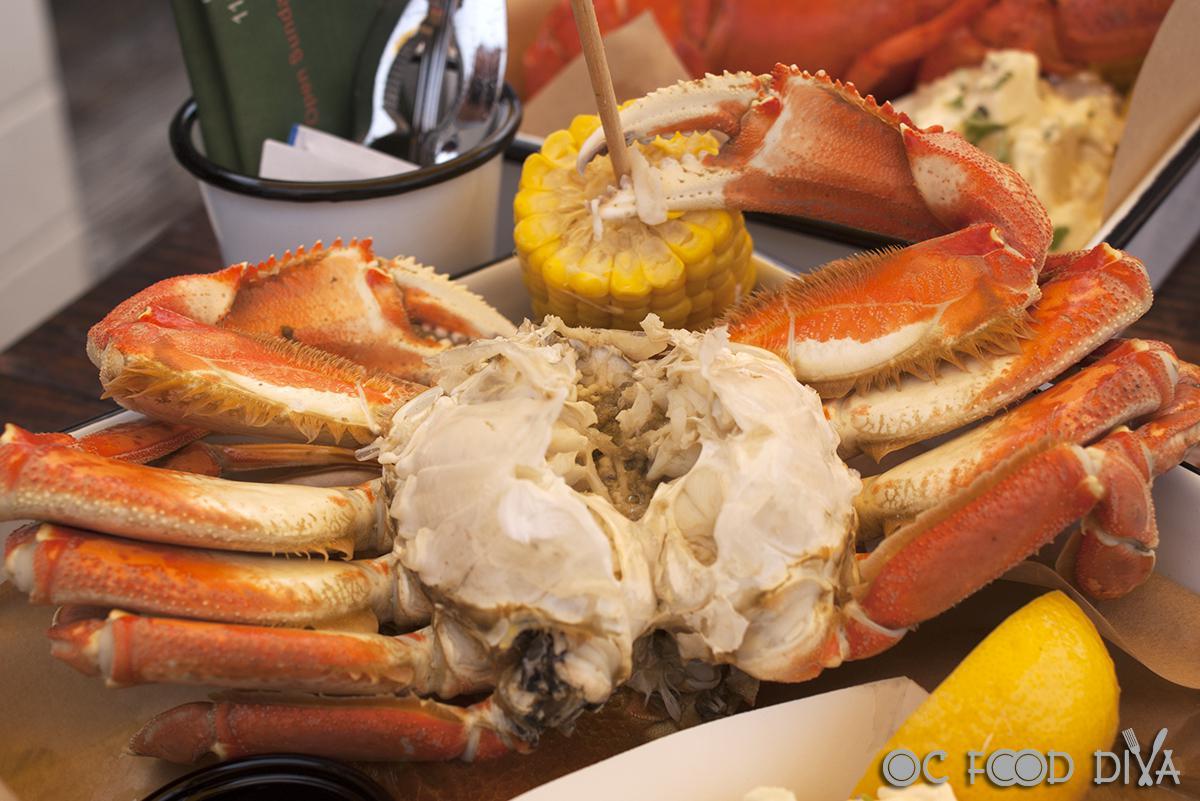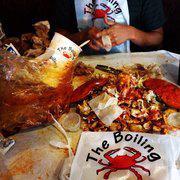The first image is the image on the left, the second image is the image on the right. Assess this claim about the two images: "there is crab ready to serve with a wedge of lemon next to it". Correct or not? Answer yes or no. Yes. The first image is the image on the left, the second image is the image on the right. Analyze the images presented: Is the assertion "In at least one image there is a single cooked crab upside down exposing it's soft parts." valid? Answer yes or no. Yes. 